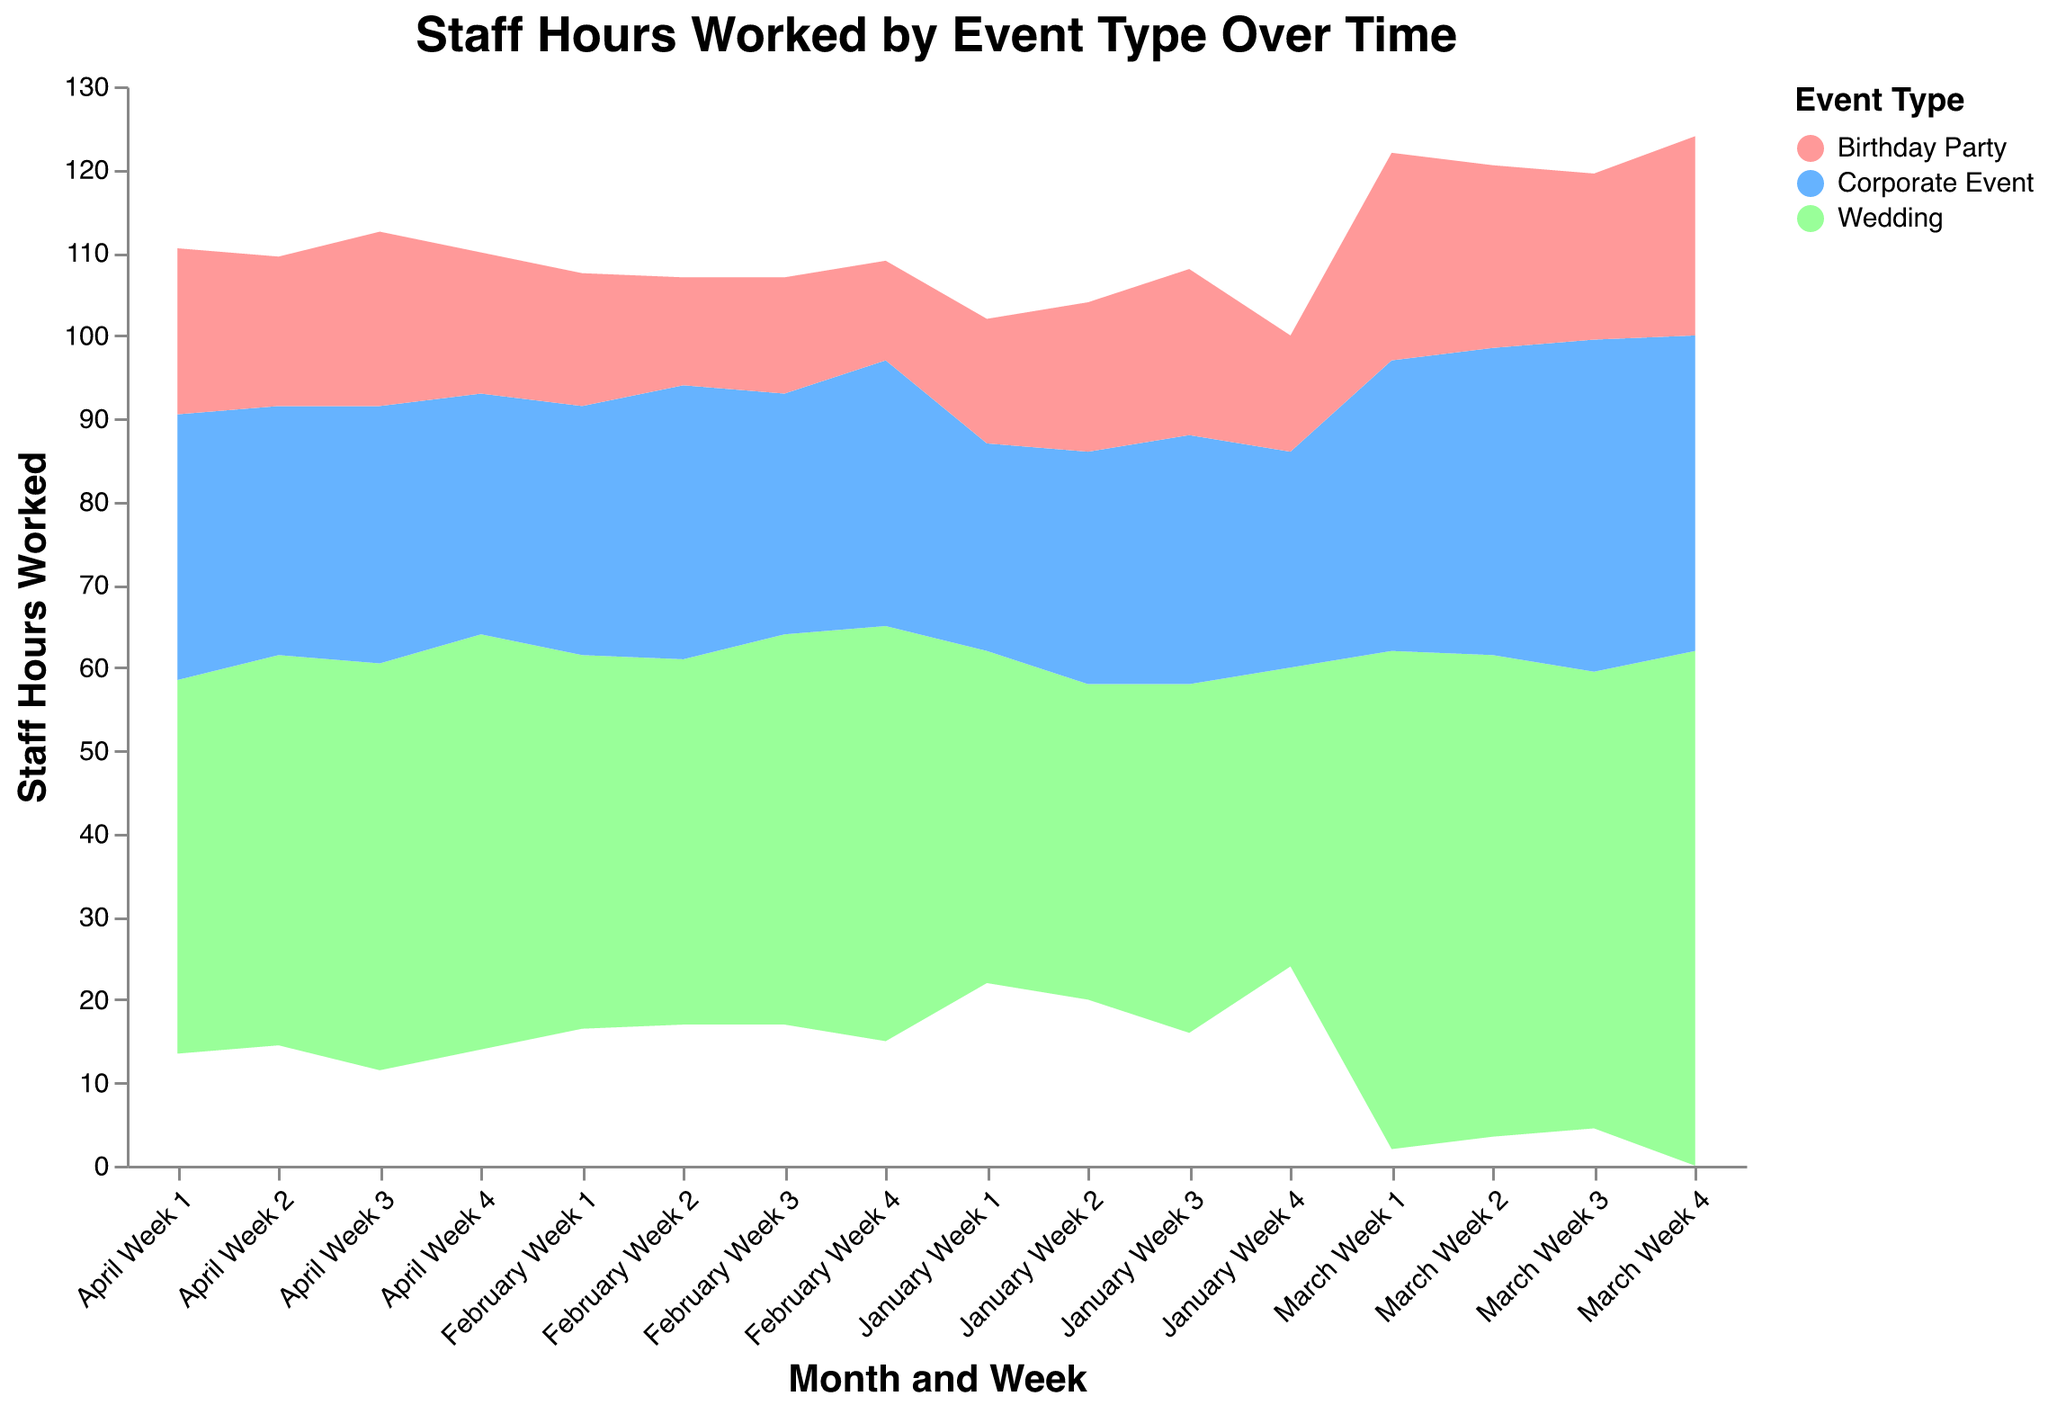What is the title of the figure? The title is usually located at the top of the visualization and describes the overall theme. Here, it specifies the content, which is "Staff Hours Worked by Event Type Over Time."
Answer: Staff Hours Worked by Event Type Over Time How many types of events are shown in the figure? The color legend at the right side of the figure lists all the event types represented in the visualization.
Answer: 3 What was the general trend in staff hours worked for weddings? By observing the stream corresponding to weddings, it generally increases over time, peaking in March and slightly decreasing in April.
Answer: Increased to a peak in March, then slightly decreased How do the staff hours worked for birthday parties in January compare to those in March? The height of the area representing birthday parties for January and March weeks must be compared. In January, the staff hours are lower, while in March, they are higher but fluctuate within the same range.
Answer: Higher in March than in January Which month had the highest total staff hours worked across all event types, and how can you tell? Summing up the heights of the streams for all event types across each month will show the total staff hours. March has higher peaks and larger areas overall than other months.
Answer: March What is the average number of staff hours worked for corporate events in February? Add up the staff hours for all weeks in February for corporate events and divide by the number of weeks (4). (30 + 33 + 29 + 32) / 4 = 31
Answer: 31 hours Which week in March had the highest staff hours worked across all event types? The peak of all stacked area streams in March represents the highest total staff hours. The last week of March shows the highest cumulative peak.
Answer: Week 4 What is the difference in staff hours worked between weddings and corporate events in the second week of January? Subtract the staff hours for corporate events from the staff hours for weddings in the second week of January (38 - 28).
Answer: 10 hours How many weeks had less than 20 staff hours worked for birthday parties? Observe the heights of the area corresponding to birthday parties; sum up the weeks where it is below 20. Weeks: January: 1,2,4 and February: 2,3,4
Answer: 6 weeks In which week did weddings have their highest staff hours worked, and how does it compare to the lowest staff hours week for weddings? The highest staff hours for weddings are in the 4th week of March (62), and the lowest is in the 4th week of January (36). The difference is 62 - 36.
Answer: 4th week of March; 26 hours more 